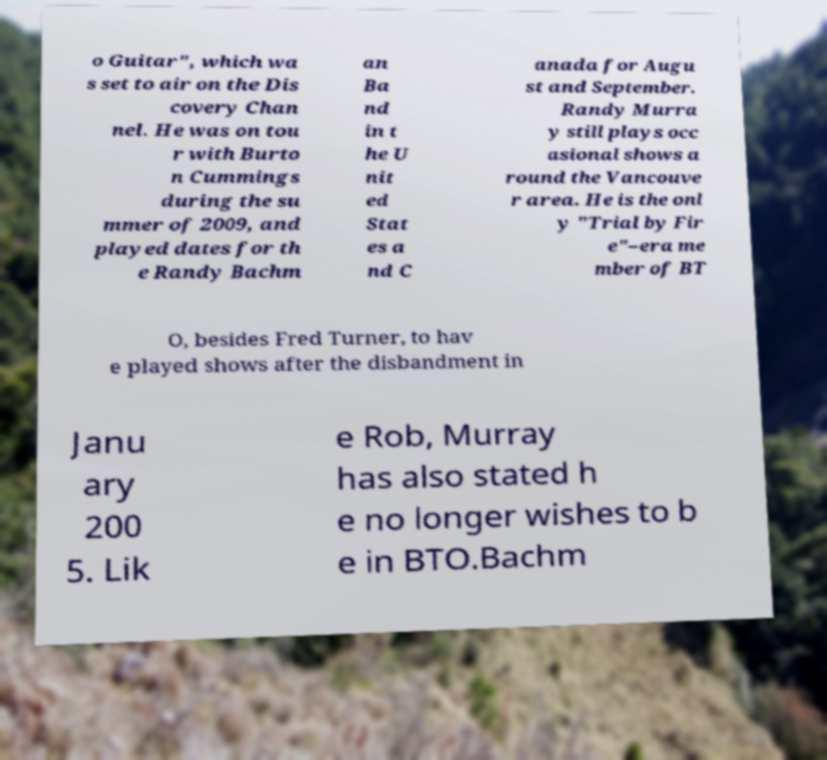Please identify and transcribe the text found in this image. o Guitar", which wa s set to air on the Dis covery Chan nel. He was on tou r with Burto n Cummings during the su mmer of 2009, and played dates for th e Randy Bachm an Ba nd in t he U nit ed Stat es a nd C anada for Augu st and September. Randy Murra y still plays occ asional shows a round the Vancouve r area. He is the onl y "Trial by Fir e"–era me mber of BT O, besides Fred Turner, to hav e played shows after the disbandment in Janu ary 200 5. Lik e Rob, Murray has also stated h e no longer wishes to b e in BTO.Bachm 